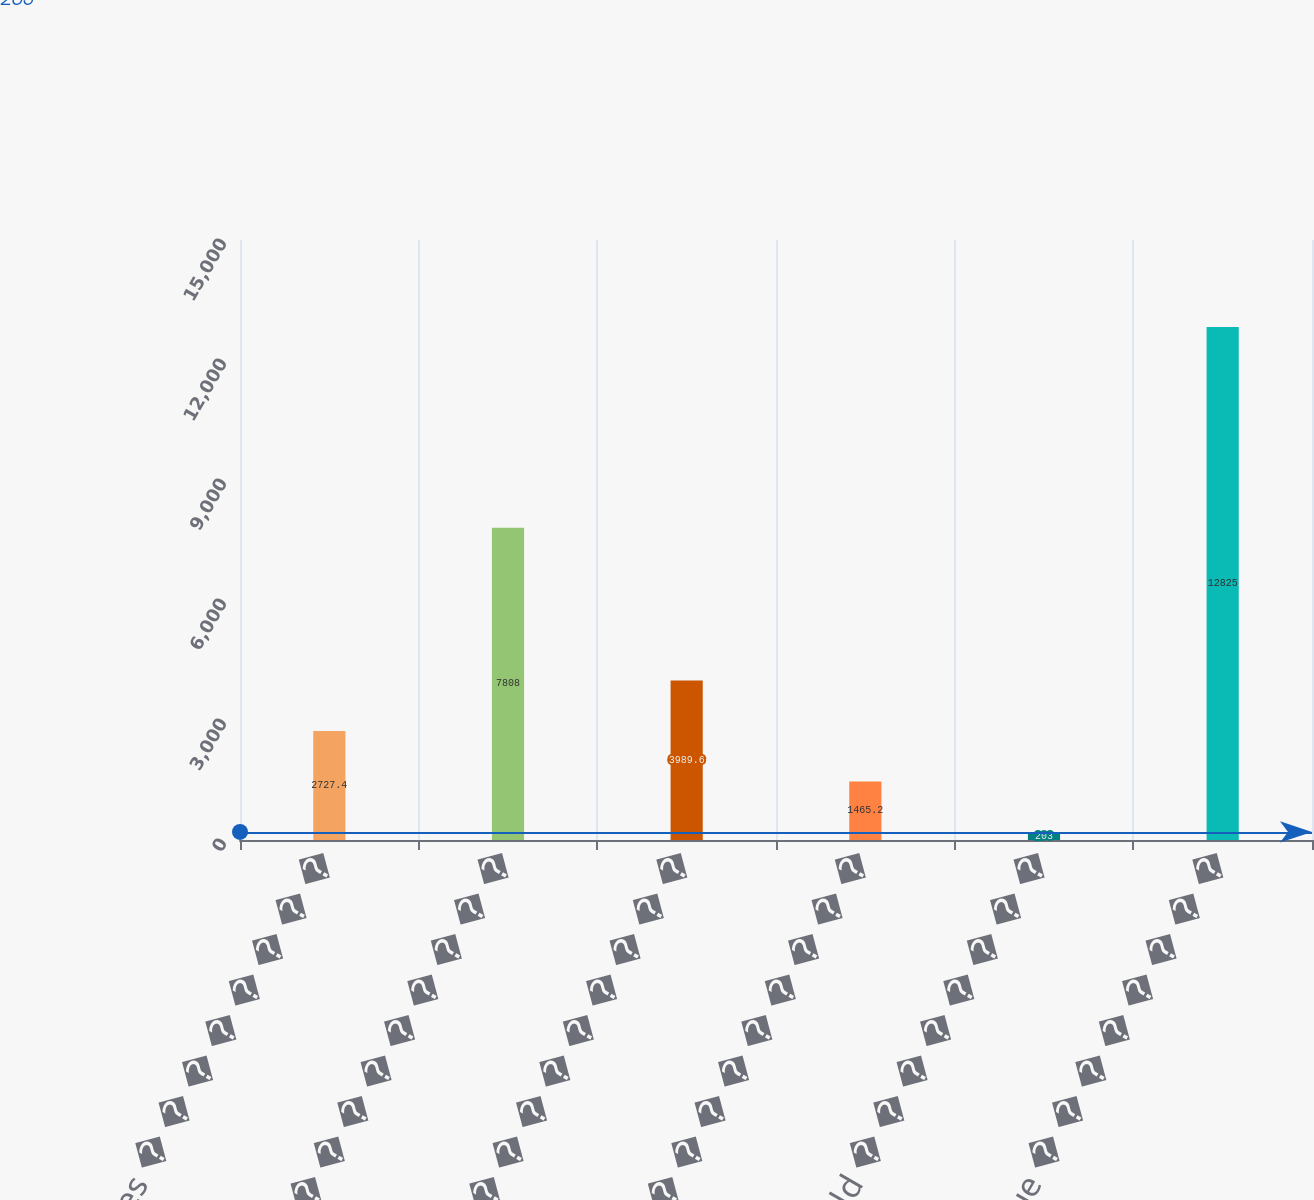Convert chart to OTSL. <chart><loc_0><loc_0><loc_500><loc_500><bar_chart><fcel>United States � � � � � � � �<fcel>Asia (a) � � � � � � � � � � �<fcel>Europe � � � � � � � � � � � �<fcel>Japan � � � � � � � � � � � �<fcel>Rest of world � � � � � � � �<fcel>Total revenue � � � � � � � �<nl><fcel>2727.4<fcel>7808<fcel>3989.6<fcel>1465.2<fcel>203<fcel>12825<nl></chart> 